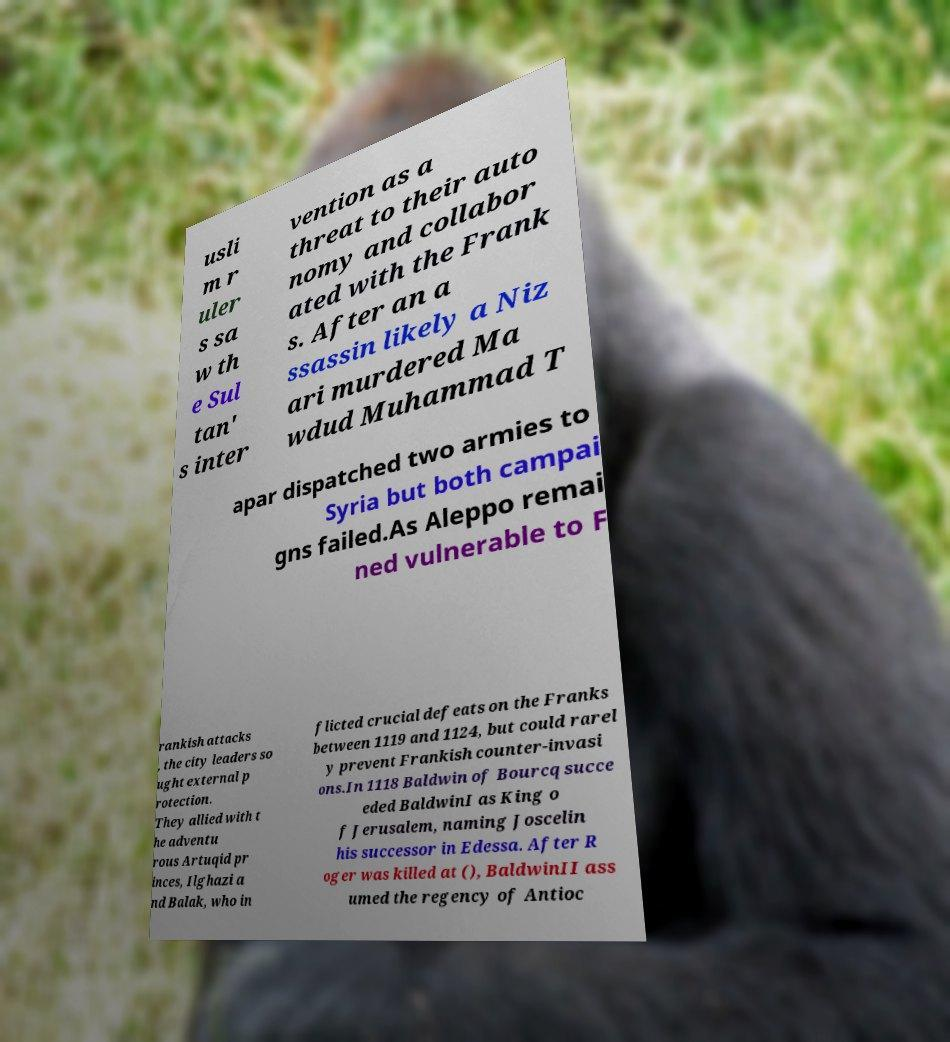Could you extract and type out the text from this image? usli m r uler s sa w th e Sul tan' s inter vention as a threat to their auto nomy and collabor ated with the Frank s. After an a ssassin likely a Niz ari murdered Ma wdud Muhammad T apar dispatched two armies to Syria but both campai gns failed.As Aleppo remai ned vulnerable to F rankish attacks , the city leaders so ught external p rotection. They allied with t he adventu rous Artuqid pr inces, Ilghazi a nd Balak, who in flicted crucial defeats on the Franks between 1119 and 1124, but could rarel y prevent Frankish counter-invasi ons.In 1118 Baldwin of Bourcq succe eded BaldwinI as King o f Jerusalem, naming Joscelin his successor in Edessa. After R oger was killed at (), BaldwinII ass umed the regency of Antioc 